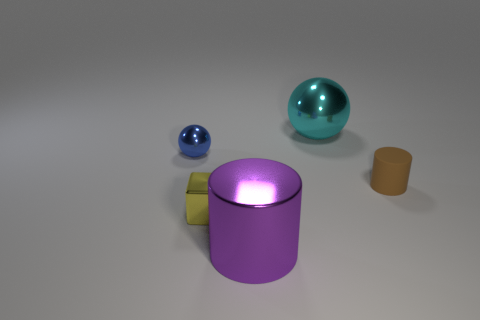What do the different colors on the objects signify? The colors of the objects might not signify anything in particular but could simply be chosen for aesthetic or illustrative purposes. However, if this were a setting with a specific context, colors could be used to differentiate between objects, indicating different properties or belonging to various groups. 